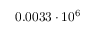Convert formula to latex. <formula><loc_0><loc_0><loc_500><loc_500>0 . 0 0 3 3 \cdot 1 0 ^ { 6 }</formula> 